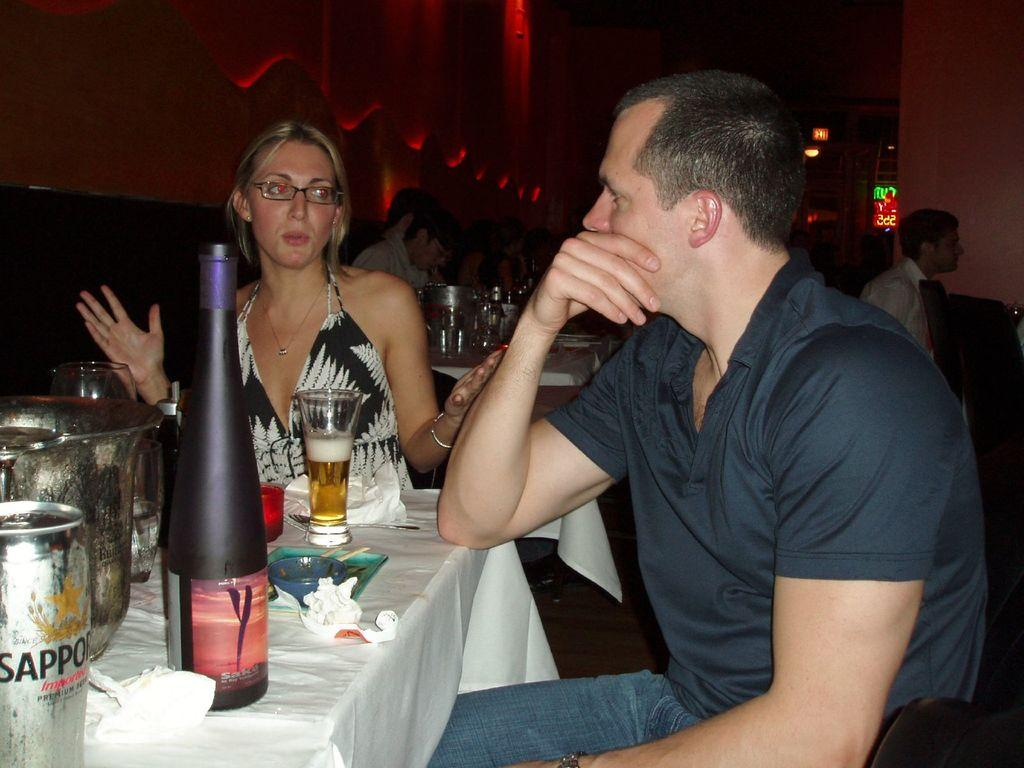<image>
Share a concise interpretation of the image provided. Man and women on a dinner date drinking alcohol and Sapporo. 